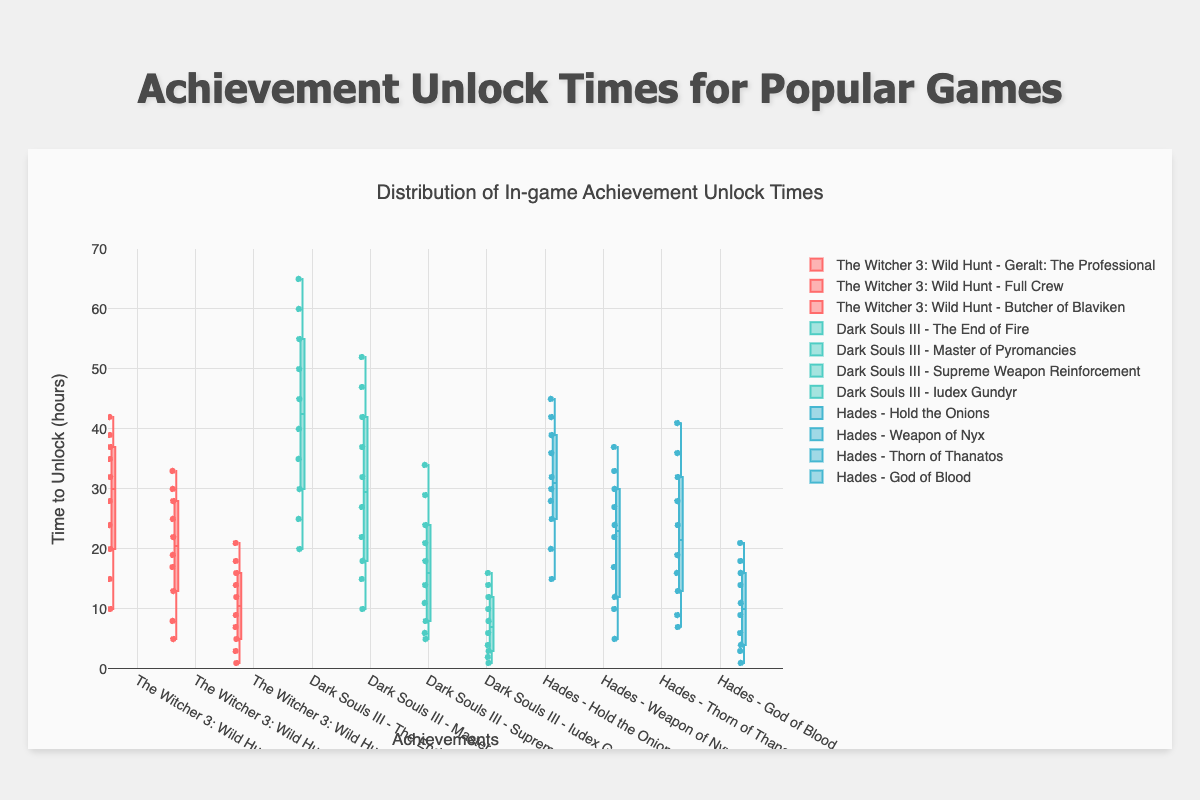What is the title of the figure? The title is typically displayed at the top or near the top of the figure and gives a quick idea of what the chart represents. In this case, it reads "Distribution of In-game Achievement Unlock Times."
Answer: Distribution of In-game Achievement Unlock Times What is the range of the Y-axis? The Y-axis typically has a range specified on one side of the plot, indicating the minimum and maximum values. Here, it ranges from 0 to 70 hours.
Answer: 0 to 70 Which game has the achievement with the highest median unlock time? The median value is the middle value of the dataset and is often marked by a line within each box in the box plot. For highest median value, check where the line within the box is the highest. This is observed for the achievement "The End of Fire" from Dark Souls III.
Answer: Dark Souls III What are the unlock times for "Geralt: The Professional" in The Witcher 3? The unlock times for this achievement in the box plot can be found by looking at the corresponding box. These times are 10, 15, 20, 24, 28, 32, 35, 37, 39, 42 hours, as seen in the data points represented by dots.
Answer: 10, 15, 20, 24, 28, 32, 35, 37, 39, 42 Which achievement has the widest interquartile range (IQR) and which game is it from? The IQR is the range between the first quartile (Q1) and the third quartile (Q3) of a box in a box plot. It represents the middle 50% of the data. The box with the widest visible IQR is for the achievement "The End of Fire" from Dark Souls III.
Answer: The End of Fire from Dark Souls III Which achievement has the smallest range of unlock times? The range is the difference between the maximum and minimum values shown in the whiskers of the box plot. For the smallest range, find the box with the smallest spread. This is for "Iudex Gundyr" from Dark Souls III.
Answer: Iudex Gundyr from Dark Souls III How does the spread of unlock times for "Hold the Onions" in Hades compare to "The End of Fire" in Dark Souls III? To compare the spread, look at the length of the whiskers and the height of the boxes. "The End of Fire" has a larger spread with more dispersed unlock times compared to "Hold the Onions."
Answer: The End of Fire has a larger spread What is the median unlock time for "Thorn of Thanatos" in Hades? The median is represented by a line within the box. For "Thorn of Thanatos," this line is at around the middle of the enclosed box, indicating a median unlock time close to 24 hours.
Answer: 24 hours How do the unlock times for "Butcher of Blaviken" in The Witcher 3 compare to "God of Blood" in Hades? Compare the box plot positions. For "Butcher of Blaviken," the values are generally smaller and the whiskers extend lower compared to "God of Blood," meaning it has shorter unlock times overall.
Answer: Butcher of Blaviken has shorter unlock times 